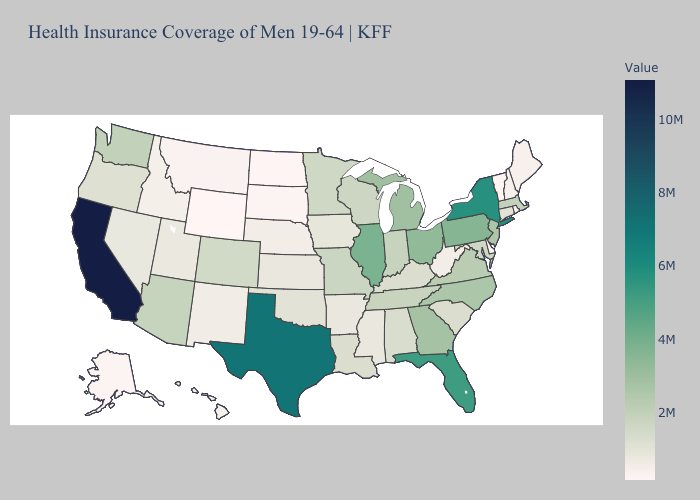Does West Virginia have the lowest value in the USA?
Give a very brief answer. No. Among the states that border California , which have the highest value?
Write a very short answer. Arizona. Does Alabama have the lowest value in the USA?
Be succinct. No. Does Washington have a higher value than Nebraska?
Keep it brief. Yes. Does Vermont have the lowest value in the Northeast?
Concise answer only. Yes. 